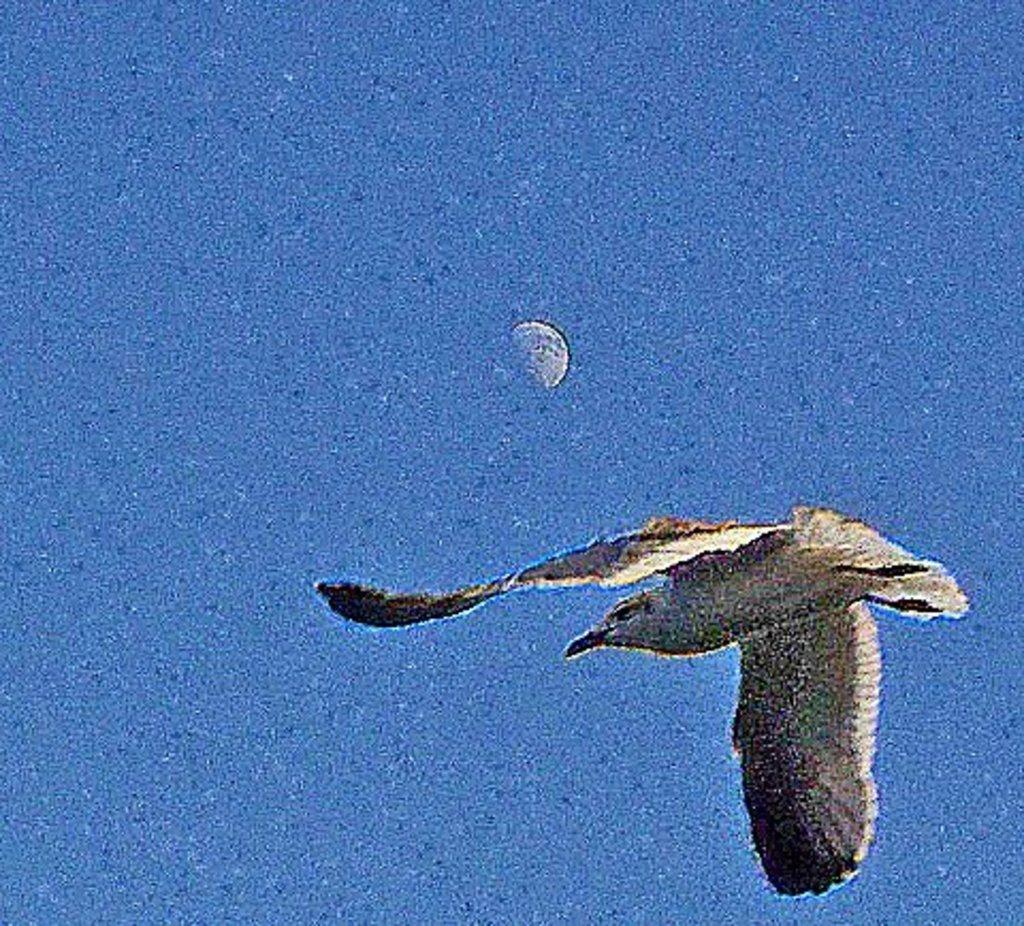What is the main subject of the image? The main subject of the image is a bird flying. What can be seen in the background of the image? The sky is visible in the image. What celestial object is present in the image? There is a half moon in the image. What type of food is the bird eating in the image? There is no food visible in the image, and the bird is flying, not eating. Can you tell me how many frogs are present in the image? There are no frogs present in the image; the main subject is a bird flying. 